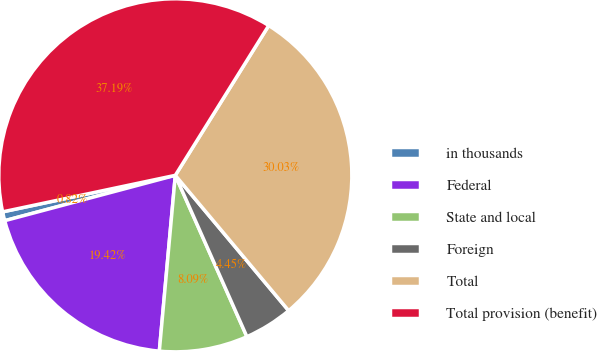Convert chart. <chart><loc_0><loc_0><loc_500><loc_500><pie_chart><fcel>in thousands<fcel>Federal<fcel>State and local<fcel>Foreign<fcel>Total<fcel>Total provision (benefit)<nl><fcel>0.82%<fcel>19.42%<fcel>8.09%<fcel>4.45%<fcel>30.03%<fcel>37.19%<nl></chart> 